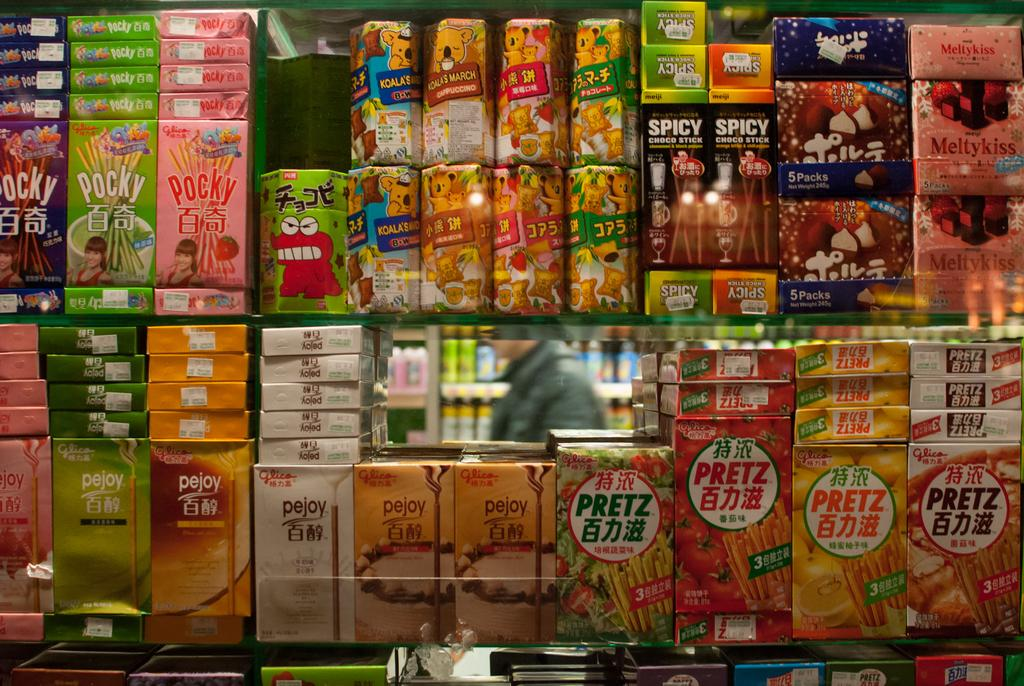<image>
Summarize the visual content of the image. A shelf full of Glico Japanese snacks featuring Pocky, Koala's March, Pretz, and Meltykiss. 